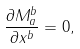Convert formula to latex. <formula><loc_0><loc_0><loc_500><loc_500>\frac { \partial M ^ { b } _ { a } } { \partial x ^ { b } } = 0 ,</formula> 